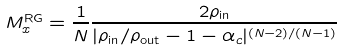<formula> <loc_0><loc_0><loc_500><loc_500>M ^ { \text {RG} } _ { x } = \frac { 1 } { N } \frac { 2 \rho _ { \text {in} } } { | \rho _ { \text {in} } / \rho _ { \text {out} } - 1 - \alpha _ { c } | ^ { ( N - 2 ) / ( N - 1 ) } }</formula> 